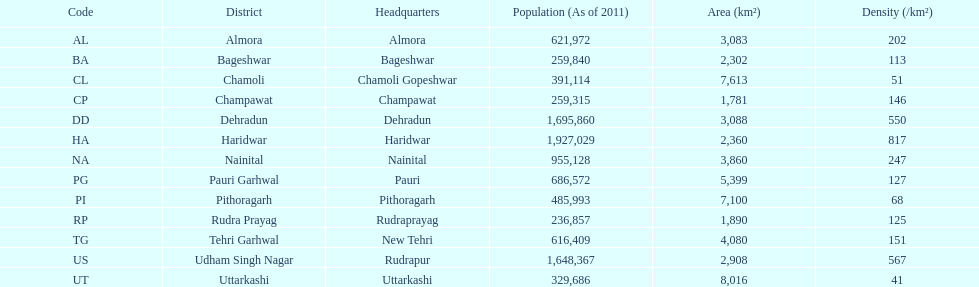Provide the quantity of districts with an area of more than 500 4. 